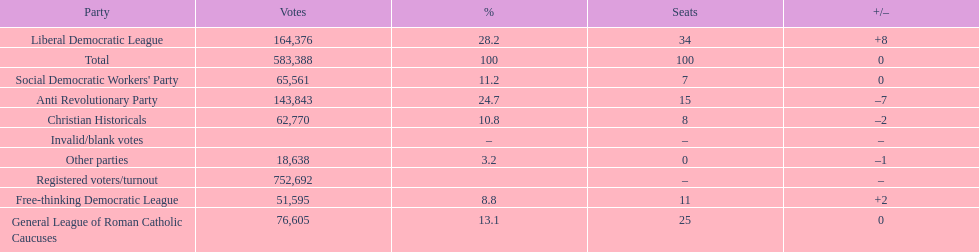How many votes were counted as invalid or blank votes? 0. 